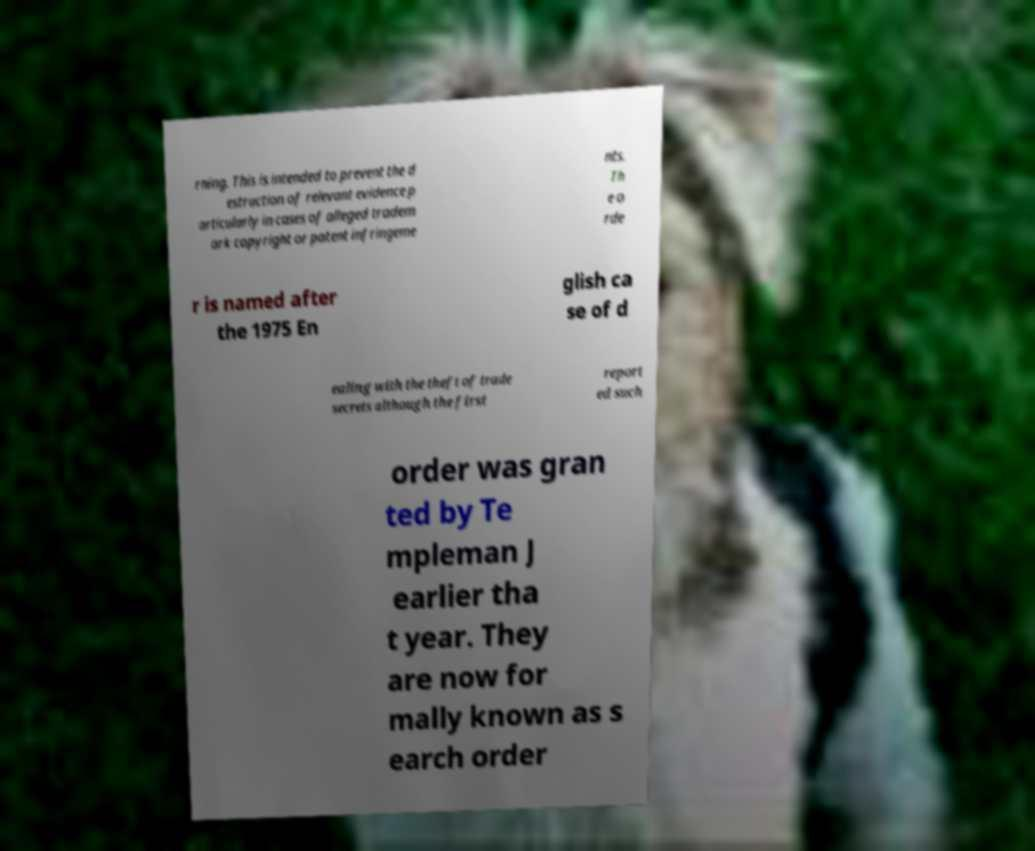Could you assist in decoding the text presented in this image and type it out clearly? rning. This is intended to prevent the d estruction of relevant evidence p articularly in cases of alleged tradem ark copyright or patent infringeme nts. Th e o rde r is named after the 1975 En glish ca se of d ealing with the theft of trade secrets although the first report ed such order was gran ted by Te mpleman J earlier tha t year. They are now for mally known as s earch order 